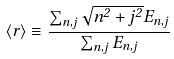<formula> <loc_0><loc_0><loc_500><loc_500>\left < r \right > \equiv \frac { \sum _ { n , j } \sqrt { n ^ { 2 } + j ^ { 2 } } E _ { n , j } } { \sum _ { n , j } E _ { n , j } }</formula> 